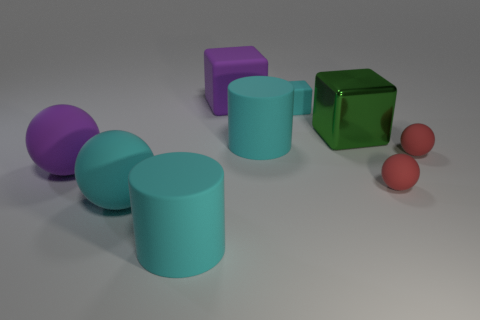What number of cylinders have the same material as the big purple block? There are two cylinders that appear to have a similar matte surface texture as the big purple block, indicating that they might be made of the same material. 